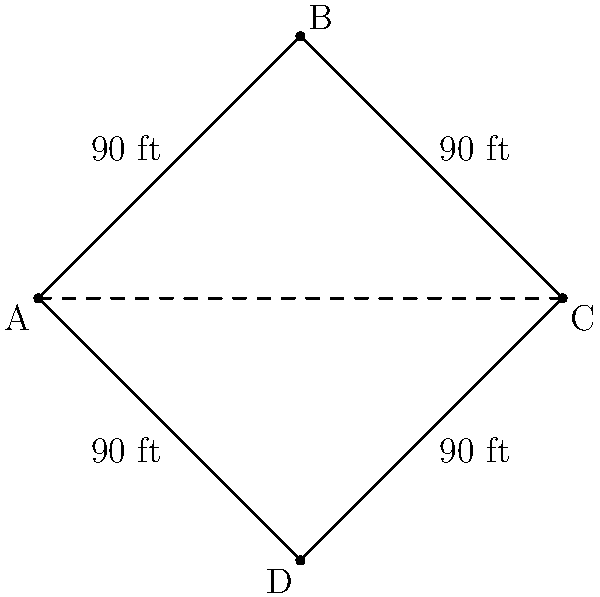In a regulation baseball diamond, the distance between consecutive bases is 90 feet. If you're standing at home plate and looking at second base, you'll notice that the diamond forms a perfect square. What is the total area of the infield (the area enclosed by the base paths)? Let's approach this step-by-step:

1) First, we need to recognize that the baseball diamond forms a square. Each side of this square is 90 feet long.

2) The area of a square is given by the formula: $A = s^2$, where $s$ is the length of a side.

3) In this case, $s = 90$ feet.

4) Let's plug this into our formula:

   $A = s^2 = 90^2 = 8,100$ square feet

5) However, this isn't our final answer. The question asks for the area of the infield, which is the area enclosed by the base paths.

6) The base paths form a diamond shape within the square. This diamond is actually a square rotated 45 degrees.

7) The area of this rotated square (our infield) is exactly half the area of the larger square we calculated.

8) Therefore, the area of the infield is:

   $A_{infield} = \frac{1}{2} \times 8,100 = 4,050$ square feet

Thus, the total area of the infield is 4,050 square feet.
Answer: 4,050 square feet 